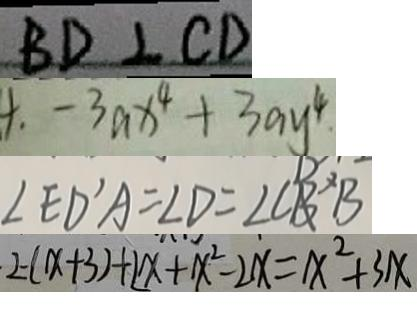<formula> <loc_0><loc_0><loc_500><loc_500>B D \bot C D 
 4 . - 3 a x ^ { 4 } + 3 a y ^ { 4 } 
 \angle E D ^ { \prime } A = \angle D = \angle C B ^ { \prime } B 
 2 - ( x + 3 ) + 2 x + x ^ { 2 } - 2 x = x ^ { 2 } + 3 x</formula> 